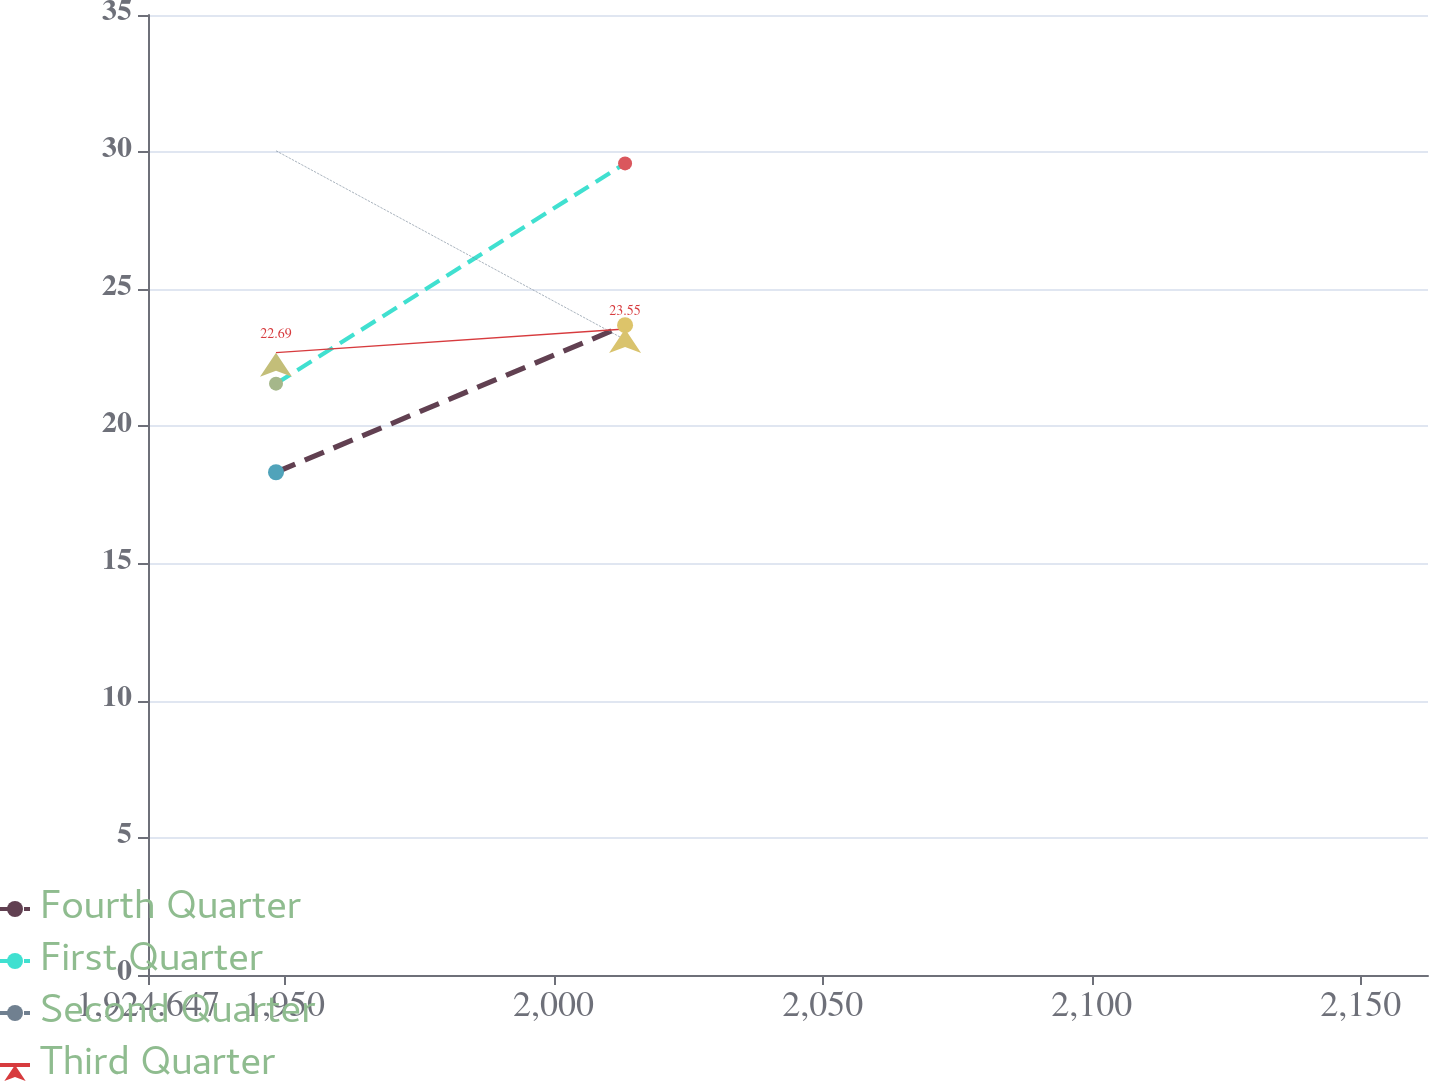<chart> <loc_0><loc_0><loc_500><loc_500><line_chart><ecel><fcel>Fourth Quarter<fcel>First Quarter<fcel>Second Quarter<fcel>Third Quarter<nl><fcel>1948.43<fcel>18.33<fcel>21.56<fcel>30.05<fcel>22.69<nl><fcel>2013.29<fcel>23.69<fcel>29.59<fcel>23.16<fcel>23.55<nl><fcel>2186.26<fcel>24.32<fcel>22.36<fcel>23.85<fcel>28.51<nl></chart> 